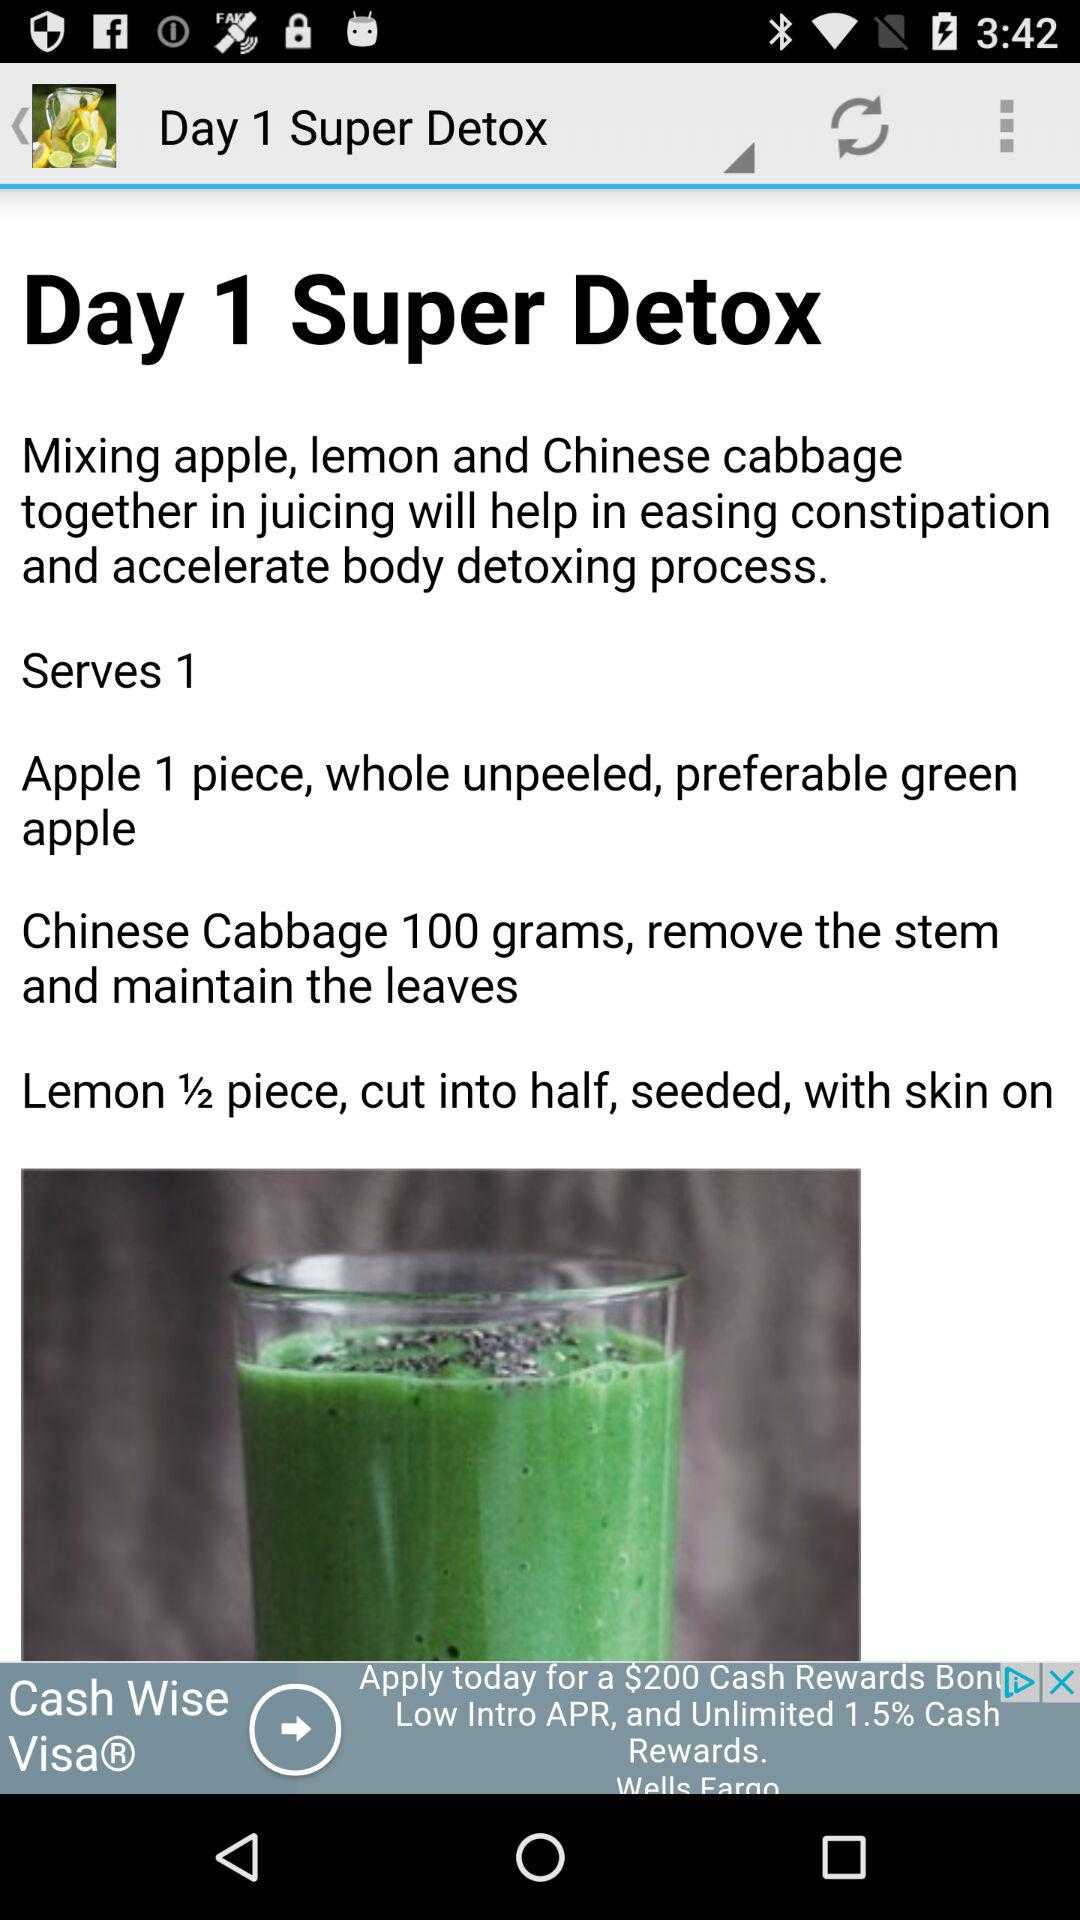How many people will be served by the "Super Detox"? The number of people who will be served by the "Super Detox" is 1. 